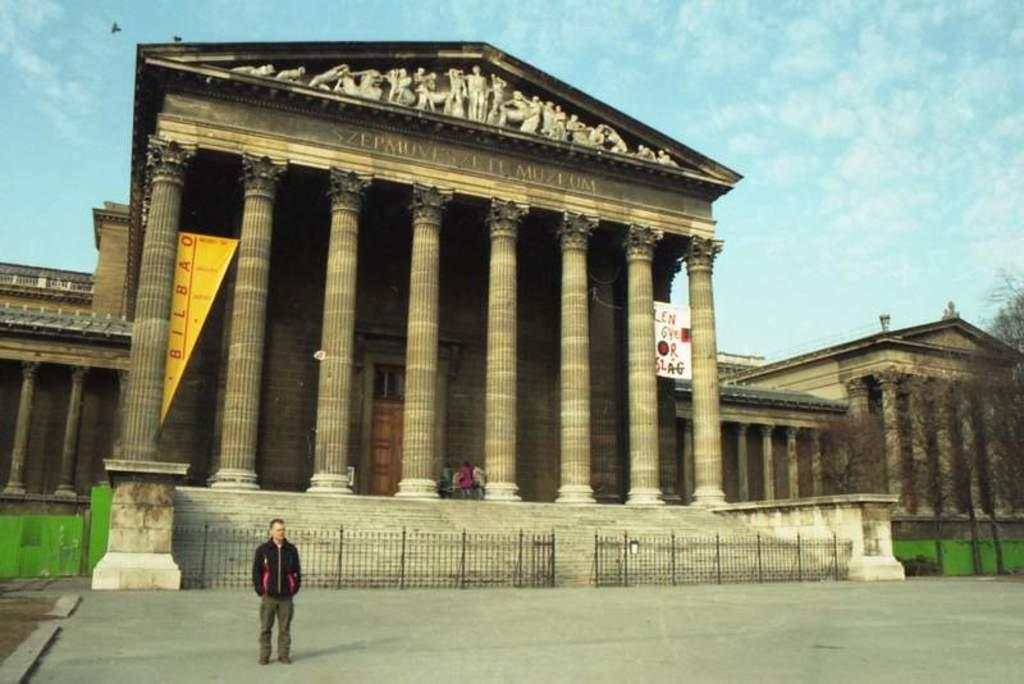What type of structures can be seen in the image? There are buildings in the image. What architectural elements are present in the image? There are pillars in the image. What type of vegetation is visible in the image? There are trees in the image. What type of signage is present in the image? There are banners in the image. What type of barrier is present in the image? There is fencing in the image. What part of the natural environment is visible in the image? The sky is visible in the image. Are there any people present in the image? Yes, there is a person standing in the image. How many brothers are playing in the dirt in the image? There are no brothers or dirt present in the image. What type of change is being made to the buildings in the image? There is no indication of any changes being made to the buildings in the image. 